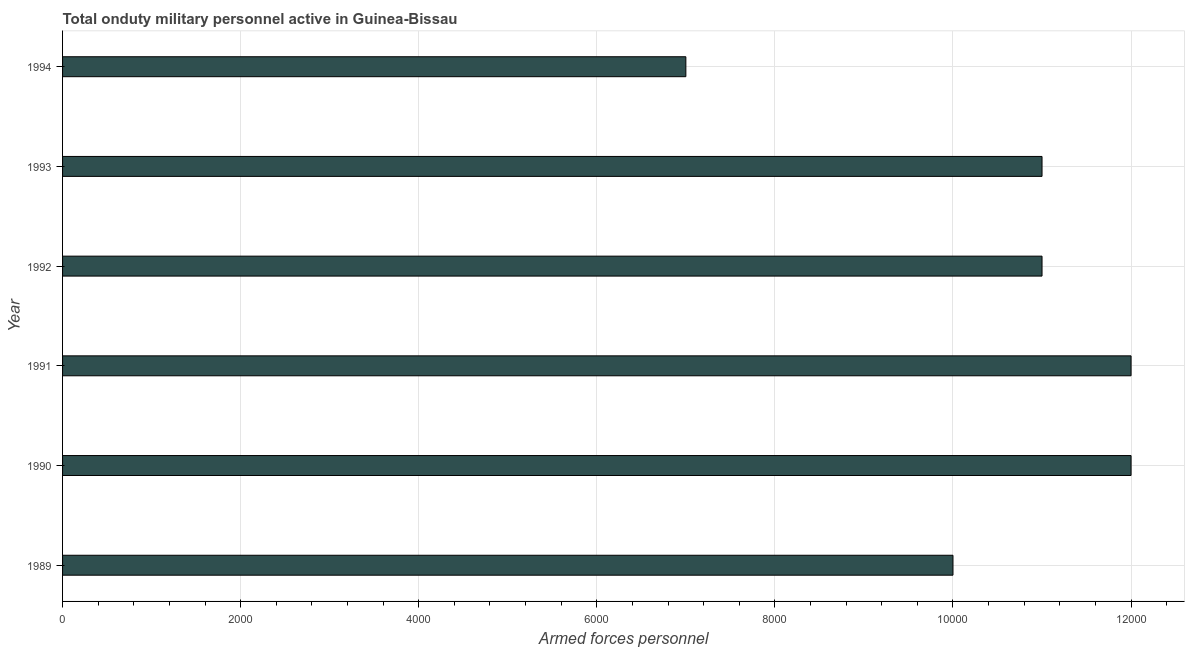What is the title of the graph?
Your response must be concise. Total onduty military personnel active in Guinea-Bissau. What is the label or title of the X-axis?
Offer a terse response. Armed forces personnel. What is the number of armed forces personnel in 1992?
Your answer should be compact. 1.10e+04. Across all years, what is the maximum number of armed forces personnel?
Your response must be concise. 1.20e+04. Across all years, what is the minimum number of armed forces personnel?
Ensure brevity in your answer.  7000. In which year was the number of armed forces personnel minimum?
Keep it short and to the point. 1994. What is the sum of the number of armed forces personnel?
Provide a succinct answer. 6.30e+04. What is the average number of armed forces personnel per year?
Make the answer very short. 1.05e+04. What is the median number of armed forces personnel?
Provide a succinct answer. 1.10e+04. What is the ratio of the number of armed forces personnel in 1989 to that in 1990?
Your response must be concise. 0.83. What is the difference between the highest and the second highest number of armed forces personnel?
Offer a very short reply. 0. What is the difference between the highest and the lowest number of armed forces personnel?
Provide a succinct answer. 5000. How many bars are there?
Offer a very short reply. 6. Are all the bars in the graph horizontal?
Offer a terse response. Yes. How many years are there in the graph?
Give a very brief answer. 6. What is the difference between two consecutive major ticks on the X-axis?
Give a very brief answer. 2000. What is the Armed forces personnel in 1989?
Ensure brevity in your answer.  10000. What is the Armed forces personnel of 1990?
Your answer should be compact. 1.20e+04. What is the Armed forces personnel in 1991?
Give a very brief answer. 1.20e+04. What is the Armed forces personnel of 1992?
Give a very brief answer. 1.10e+04. What is the Armed forces personnel in 1993?
Keep it short and to the point. 1.10e+04. What is the Armed forces personnel in 1994?
Offer a terse response. 7000. What is the difference between the Armed forces personnel in 1989 and 1990?
Keep it short and to the point. -2000. What is the difference between the Armed forces personnel in 1989 and 1991?
Keep it short and to the point. -2000. What is the difference between the Armed forces personnel in 1989 and 1992?
Provide a short and direct response. -1000. What is the difference between the Armed forces personnel in 1989 and 1993?
Provide a succinct answer. -1000. What is the difference between the Armed forces personnel in 1989 and 1994?
Your response must be concise. 3000. What is the difference between the Armed forces personnel in 1990 and 1991?
Your answer should be very brief. 0. What is the difference between the Armed forces personnel in 1990 and 1992?
Your answer should be compact. 1000. What is the difference between the Armed forces personnel in 1990 and 1993?
Your answer should be compact. 1000. What is the difference between the Armed forces personnel in 1992 and 1993?
Provide a succinct answer. 0. What is the difference between the Armed forces personnel in 1992 and 1994?
Your answer should be very brief. 4000. What is the difference between the Armed forces personnel in 1993 and 1994?
Keep it short and to the point. 4000. What is the ratio of the Armed forces personnel in 1989 to that in 1990?
Offer a terse response. 0.83. What is the ratio of the Armed forces personnel in 1989 to that in 1991?
Your answer should be compact. 0.83. What is the ratio of the Armed forces personnel in 1989 to that in 1992?
Provide a short and direct response. 0.91. What is the ratio of the Armed forces personnel in 1989 to that in 1993?
Keep it short and to the point. 0.91. What is the ratio of the Armed forces personnel in 1989 to that in 1994?
Your answer should be compact. 1.43. What is the ratio of the Armed forces personnel in 1990 to that in 1991?
Offer a very short reply. 1. What is the ratio of the Armed forces personnel in 1990 to that in 1992?
Provide a short and direct response. 1.09. What is the ratio of the Armed forces personnel in 1990 to that in 1993?
Provide a succinct answer. 1.09. What is the ratio of the Armed forces personnel in 1990 to that in 1994?
Give a very brief answer. 1.71. What is the ratio of the Armed forces personnel in 1991 to that in 1992?
Your answer should be very brief. 1.09. What is the ratio of the Armed forces personnel in 1991 to that in 1993?
Provide a short and direct response. 1.09. What is the ratio of the Armed forces personnel in 1991 to that in 1994?
Provide a short and direct response. 1.71. What is the ratio of the Armed forces personnel in 1992 to that in 1994?
Your answer should be very brief. 1.57. What is the ratio of the Armed forces personnel in 1993 to that in 1994?
Your response must be concise. 1.57. 